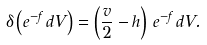Convert formula to latex. <formula><loc_0><loc_0><loc_500><loc_500>\delta \left ( e ^ { - f } \, d V \right ) = \left ( \frac { v } { 2 } - h \right ) \, e ^ { - f } \, d V .</formula> 